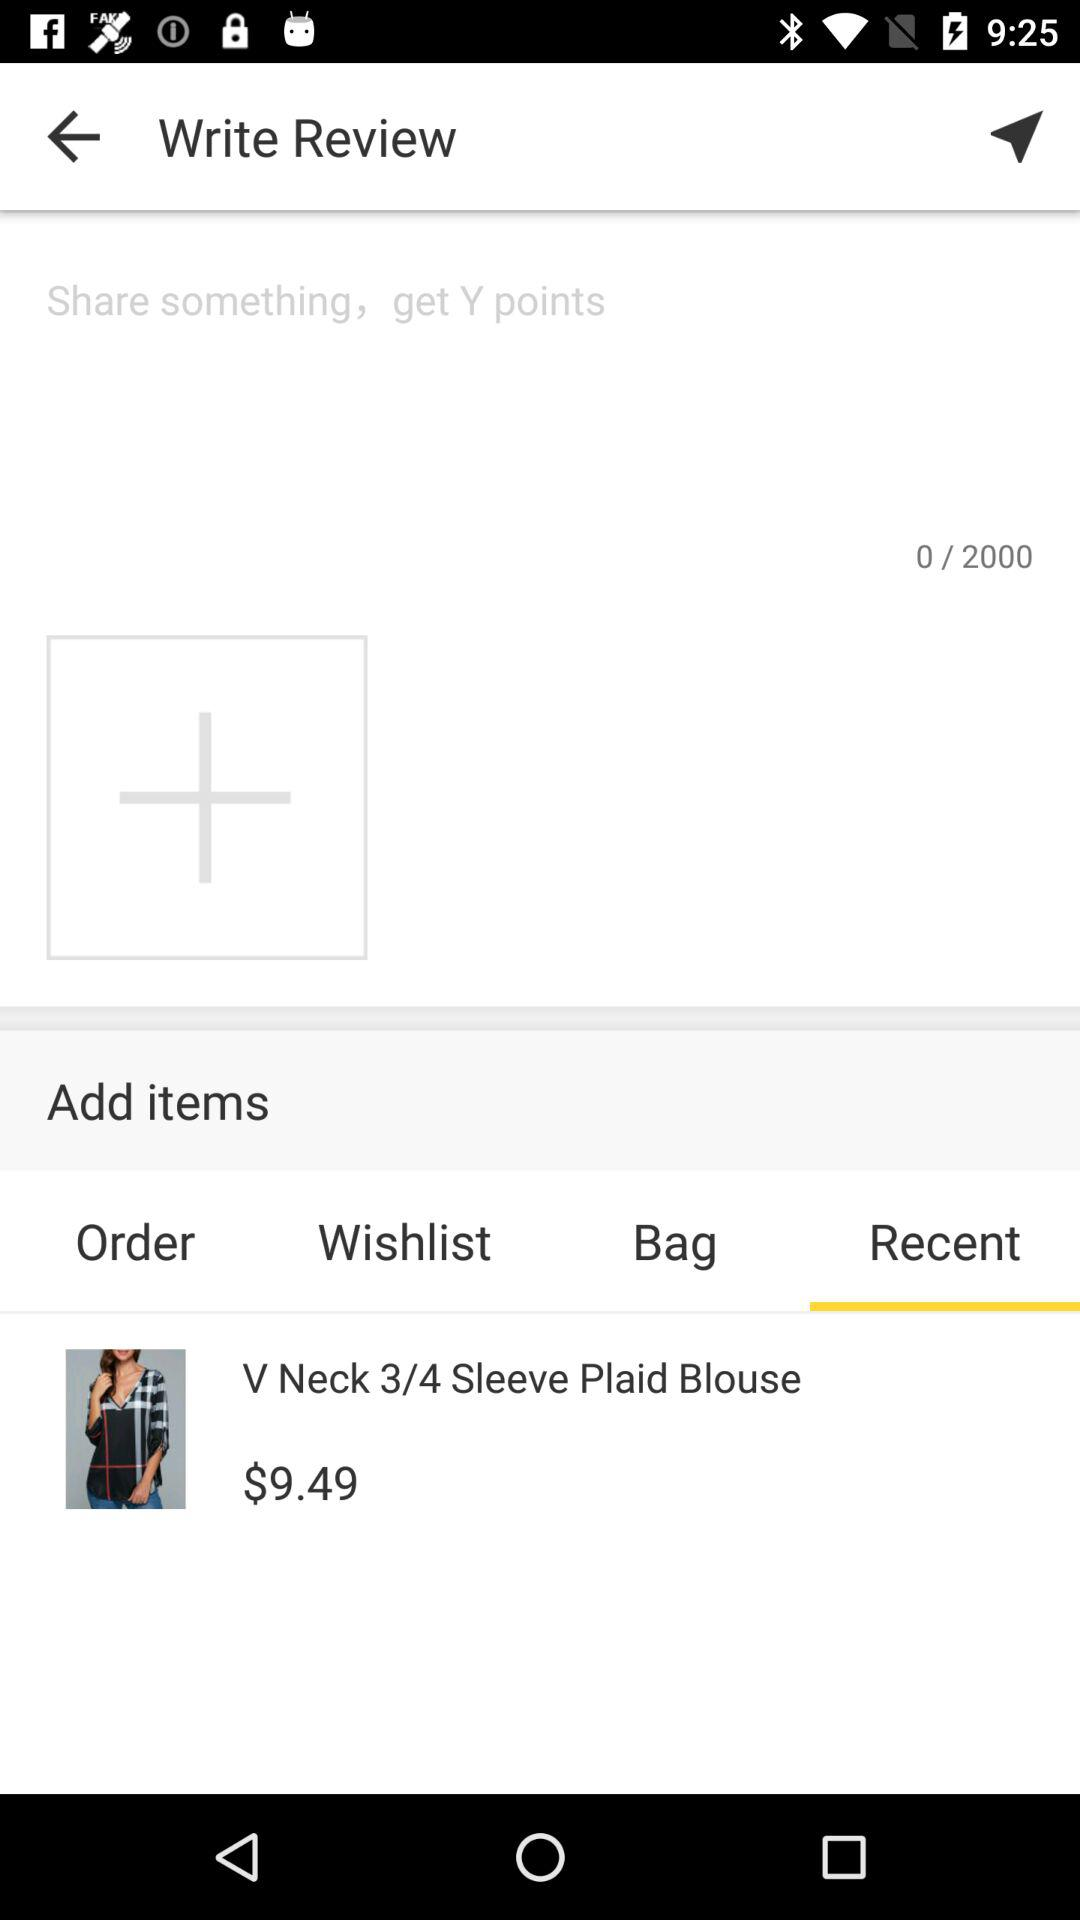What is the maximum word limit for writing a review? The maximum word limit for writing a review is 2000. 